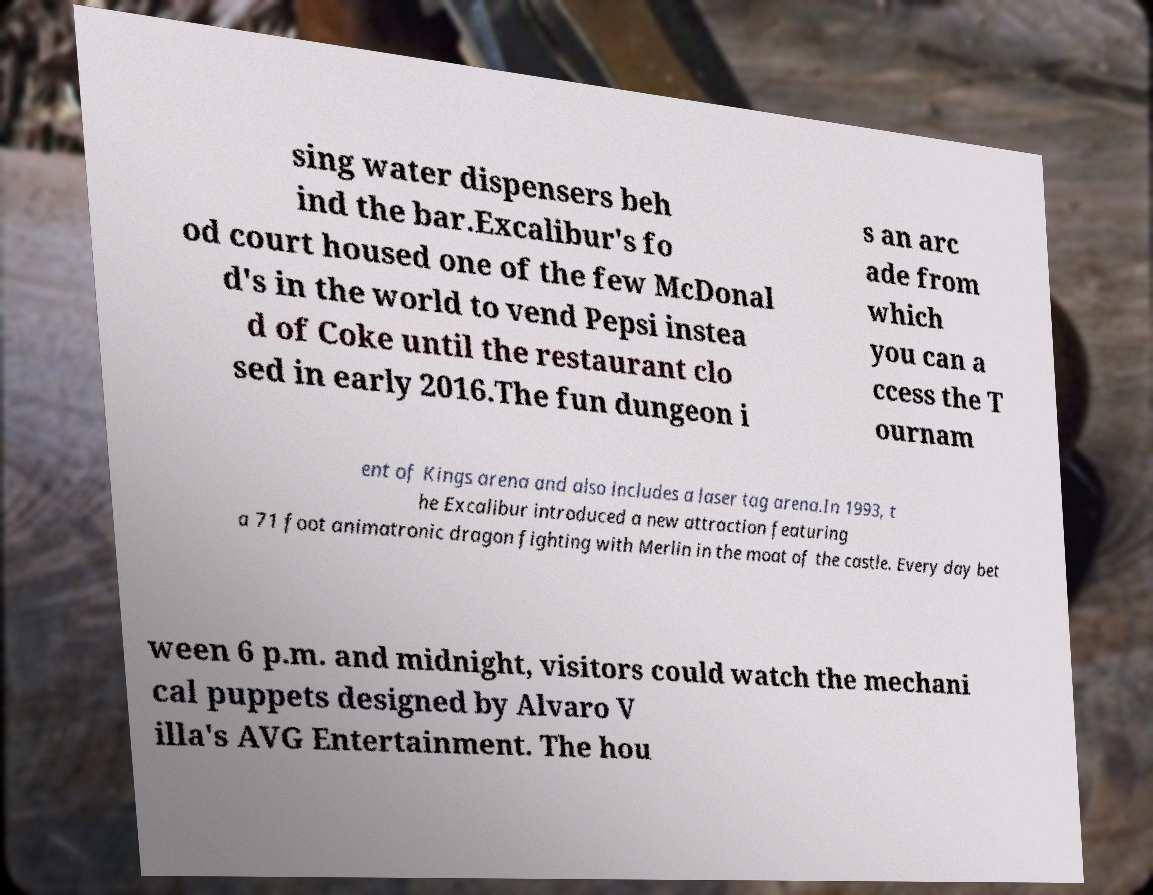Could you extract and type out the text from this image? sing water dispensers beh ind the bar.Excalibur's fo od court housed one of the few McDonal d's in the world to vend Pepsi instea d of Coke until the restaurant clo sed in early 2016.The fun dungeon i s an arc ade from which you can a ccess the T ournam ent of Kings arena and also includes a laser tag arena.In 1993, t he Excalibur introduced a new attraction featuring a 71 foot animatronic dragon fighting with Merlin in the moat of the castle. Every day bet ween 6 p.m. and midnight, visitors could watch the mechani cal puppets designed by Alvaro V illa's AVG Entertainment. The hou 